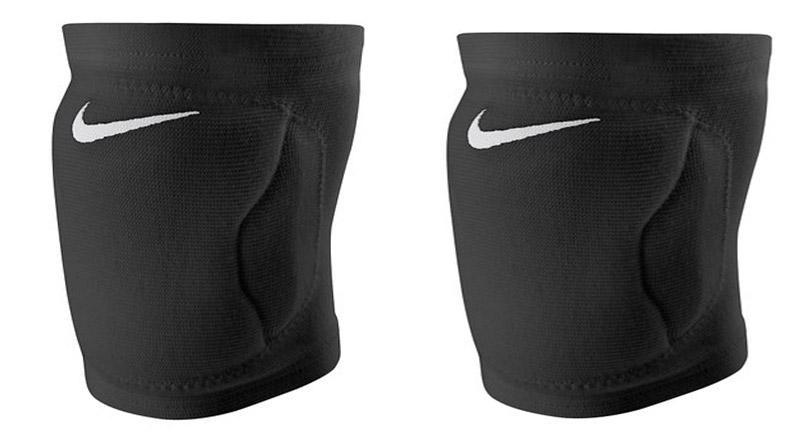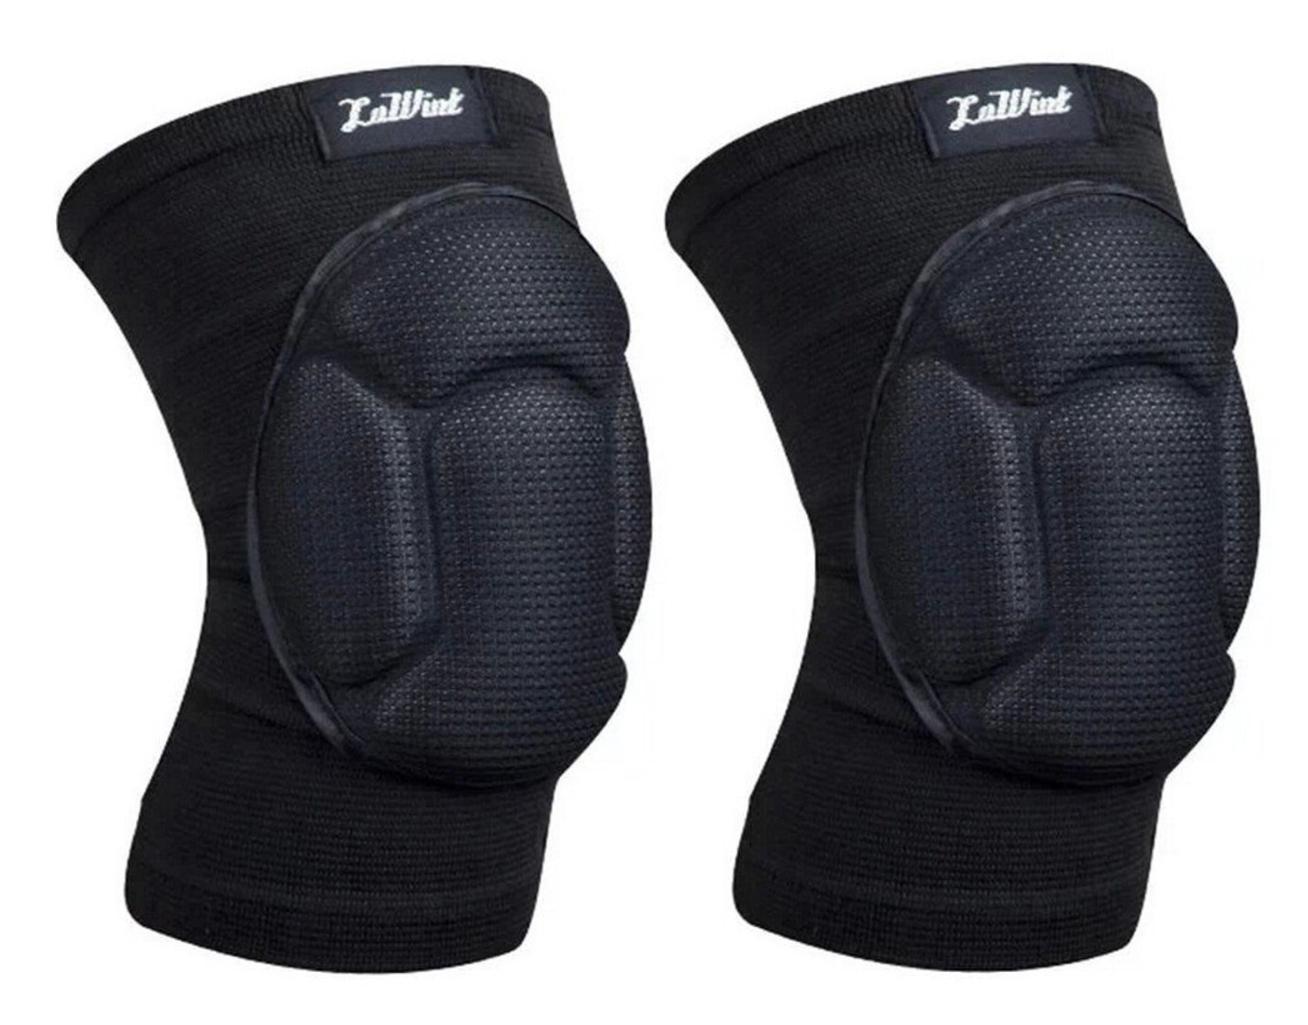The first image is the image on the left, the second image is the image on the right. Considering the images on both sides, is "At least one of the knee braces is white." valid? Answer yes or no. No. The first image is the image on the left, the second image is the image on the right. Given the left and right images, does the statement "The combined images include two black knee pads worn on bent human knees that face right." hold true? Answer yes or no. No. 